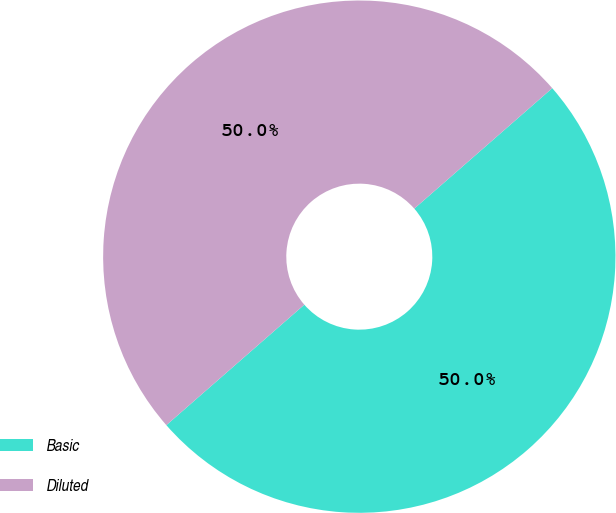Convert chart to OTSL. <chart><loc_0><loc_0><loc_500><loc_500><pie_chart><fcel>Basic<fcel>Diluted<nl><fcel>50.0%<fcel>50.0%<nl></chart> 